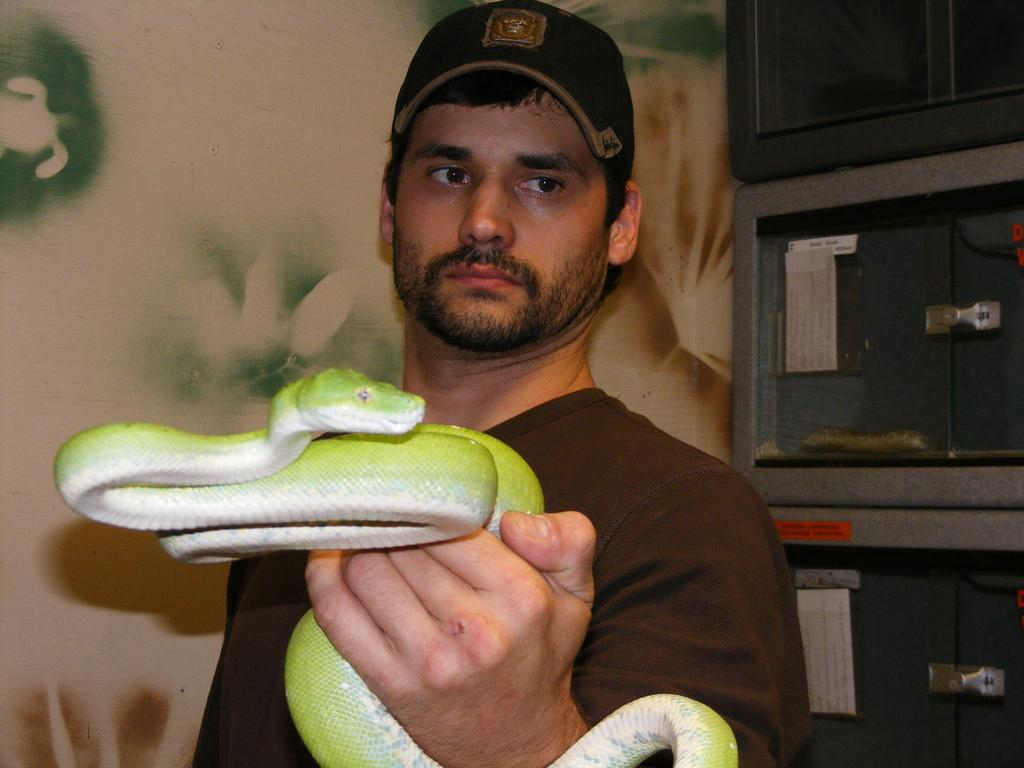Who is the main subject in the image? There is a man in the center of the image. What is the man holding in his hand? The man is holding a snake in his hand. Can you describe the man's attire? The man is wearing a cap. What can be seen in the background of the image? There are lockers and a wall in the background of the image. Can you tell me what type of vessel is floating on the lake in the image? There is no lake or vessel present in the image; it features a man holding a snake and a background with lockers and a wall. What type of prison can be seen in the image? There is no prison present in the image; it features a man holding a snake and a background with lockers and a wall. 